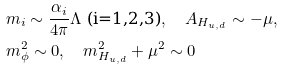<formula> <loc_0><loc_0><loc_500><loc_500>& m _ { i } \sim \frac { \alpha _ { i } } { 4 \pi } \Lambda \text {  (i=1,2,3)} , \quad A _ { H _ { u , d } } \sim - \mu , \\ & m ^ { 2 } _ { \phi } \sim 0 , \quad m ^ { 2 } _ { H _ { u , d } } + \mu ^ { 2 } \sim 0</formula> 